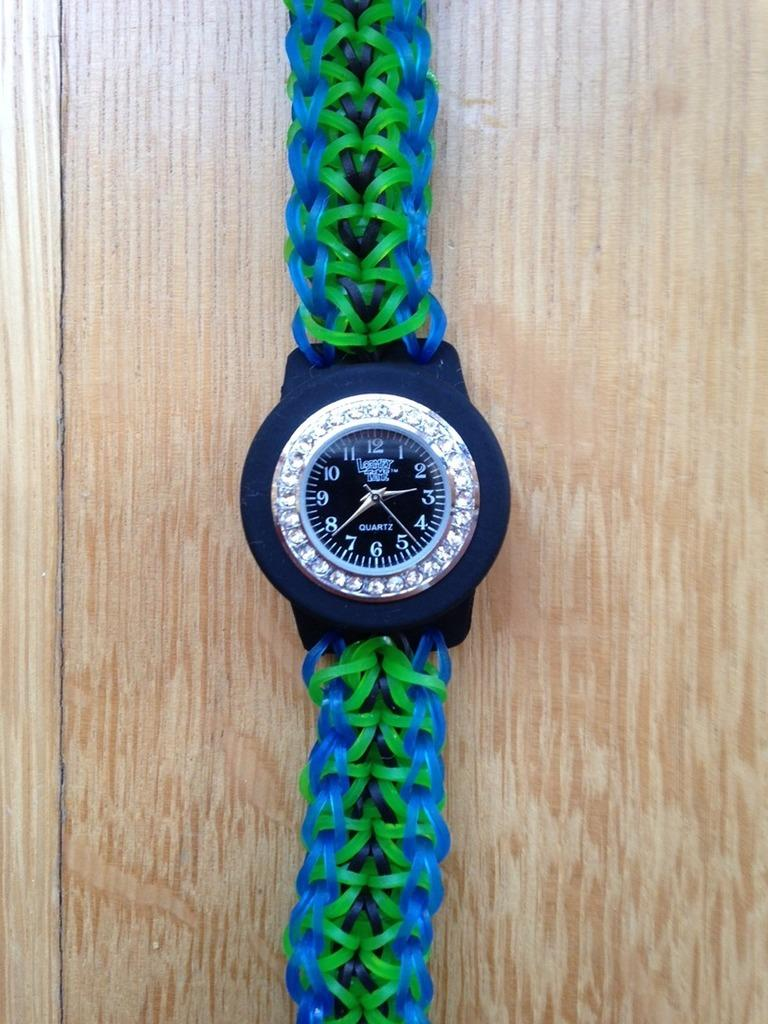Provide a one-sentence caption for the provided image. A Quartz watch with a band made out of rubber bands. 